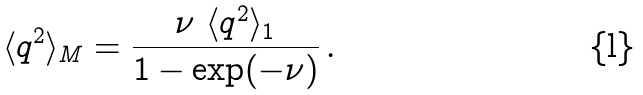Convert formula to latex. <formula><loc_0><loc_0><loc_500><loc_500>\langle q ^ { 2 } \rangle _ { M } = \frac { \nu \ \langle q ^ { 2 } \rangle _ { 1 } } { 1 - \exp ( - \nu ) } \, .</formula> 